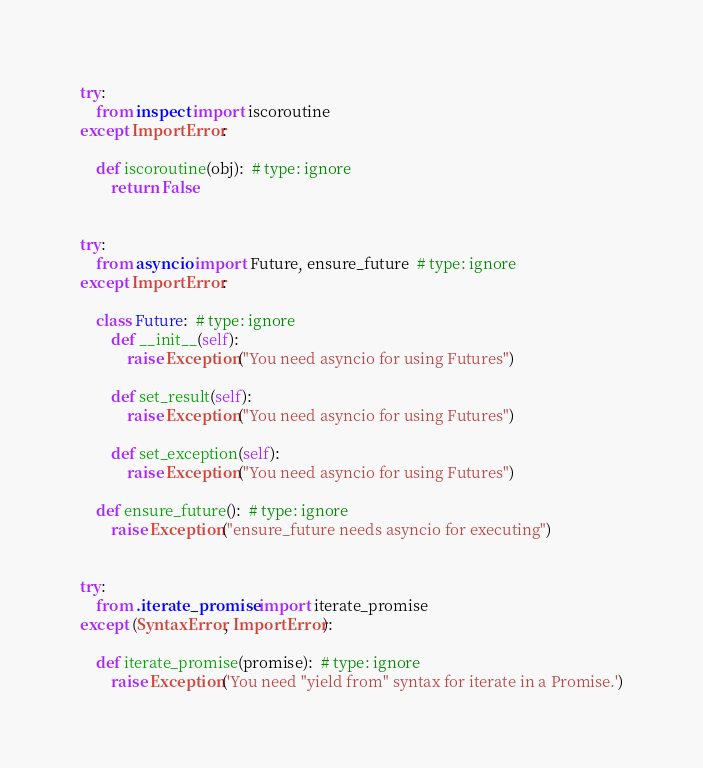Convert code to text. <code><loc_0><loc_0><loc_500><loc_500><_Python_>try:
    from inspect import iscoroutine
except ImportError:

    def iscoroutine(obj):  # type: ignore
        return False


try:
    from asyncio import Future, ensure_future  # type: ignore
except ImportError:

    class Future:  # type: ignore
        def __init__(self):
            raise Exception("You need asyncio for using Futures")

        def set_result(self):
            raise Exception("You need asyncio for using Futures")

        def set_exception(self):
            raise Exception("You need asyncio for using Futures")

    def ensure_future():  # type: ignore
        raise Exception("ensure_future needs asyncio for executing")


try:
    from .iterate_promise import iterate_promise
except (SyntaxError, ImportError):

    def iterate_promise(promise):  # type: ignore
        raise Exception('You need "yield from" syntax for iterate in a Promise.')
</code> 